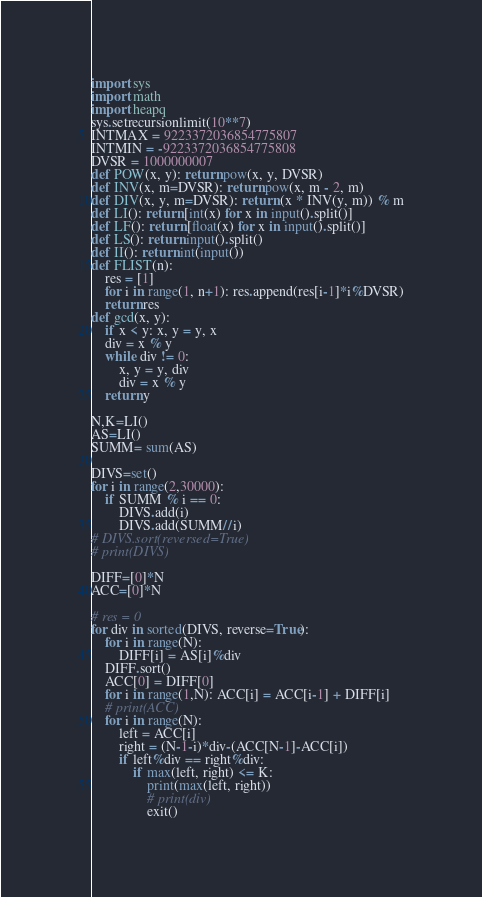Convert code to text. <code><loc_0><loc_0><loc_500><loc_500><_Python_>import sys
import math
import heapq
sys.setrecursionlimit(10**7)
INTMAX = 9223372036854775807
INTMIN = -9223372036854775808
DVSR = 1000000007
def POW(x, y): return pow(x, y, DVSR)
def INV(x, m=DVSR): return pow(x, m - 2, m)
def DIV(x, y, m=DVSR): return (x * INV(y, m)) % m
def LI(): return [int(x) for x in input().split()]
def LF(): return [float(x) for x in input().split()]
def LS(): return input().split()
def II(): return int(input())
def FLIST(n):
    res = [1]
    for i in range(1, n+1): res.append(res[i-1]*i%DVSR)
    return res
def gcd(x, y):
    if x < y: x, y = y, x
    div = x % y
    while div != 0:
        x, y = y, div
        div = x % y
    return y

N,K=LI()
AS=LI()
SUMM= sum(AS)

DIVS=set()
for i in range(2,30000):
    if SUMM % i == 0:
        DIVS.add(i)
        DIVS.add(SUMM//i)
# DIVS.sort(reversed=True)
# print(DIVS)

DIFF=[0]*N
ACC=[0]*N

# res = 0
for div in sorted(DIVS, reverse=True):
    for i in range(N):
        DIFF[i] = AS[i]%div
    DIFF.sort()
    ACC[0] = DIFF[0]
    for i in range(1,N): ACC[i] = ACC[i-1] + DIFF[i]
    # print(ACC)
    for i in range(N):
        left = ACC[i]
        right = (N-1-i)*div-(ACC[N-1]-ACC[i])
        if left%div == right%div:
            if max(left, right) <= K:
                print(max(left, right))
                # print(div)
                exit()
</code> 